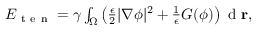Convert formula to latex. <formula><loc_0><loc_0><loc_500><loc_500>\begin{array} { r } { E _ { t e n } = \gamma \int _ { \Omega } \left ( \frac { \epsilon } { 2 } | \nabla \phi | ^ { 2 } + \frac { 1 } { \epsilon } G ( \phi ) \right ) d r , } \end{array}</formula> 